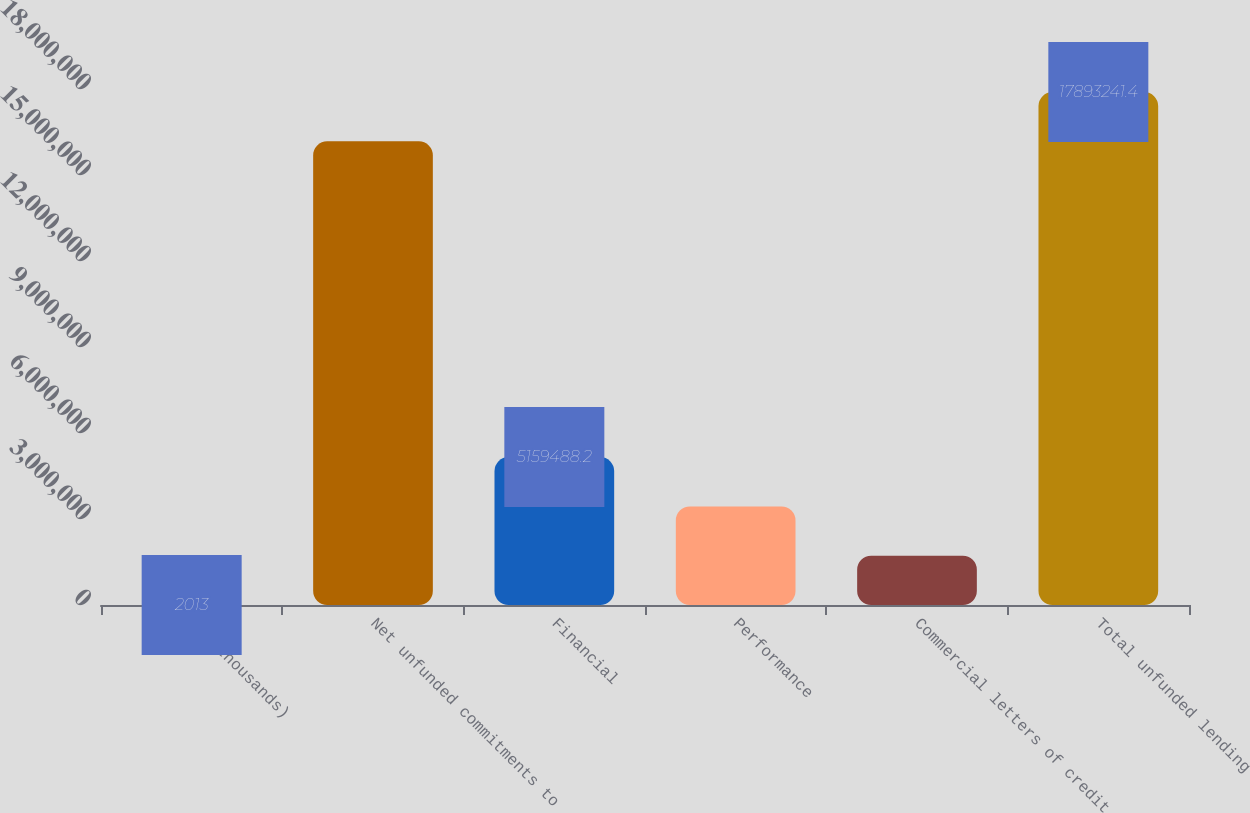Convert chart to OTSL. <chart><loc_0><loc_0><loc_500><loc_500><bar_chart><fcel>(In thousands)<fcel>Net unfunded commitments to<fcel>Financial<fcel>Performance<fcel>Commercial letters of credit<fcel>Total unfunded lending<nl><fcel>2013<fcel>1.61741e+07<fcel>5.15949e+06<fcel>3.44033e+06<fcel>1.72117e+06<fcel>1.78932e+07<nl></chart> 